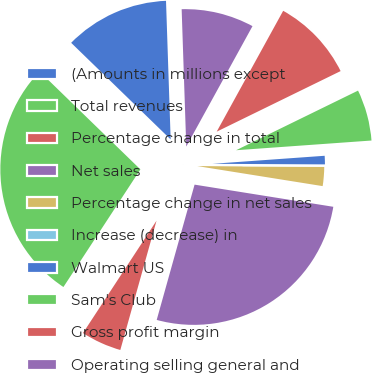<chart> <loc_0><loc_0><loc_500><loc_500><pie_chart><fcel>(Amounts in millions except<fcel>Total revenues<fcel>Percentage change in total<fcel>Net sales<fcel>Percentage change in net sales<fcel>Increase (decrease) in<fcel>Walmart US<fcel>Sam's Club<fcel>Gross profit margin<fcel>Operating selling general and<nl><fcel>12.2%<fcel>28.05%<fcel>4.88%<fcel>26.83%<fcel>2.44%<fcel>0.0%<fcel>1.22%<fcel>6.1%<fcel>9.76%<fcel>8.54%<nl></chart> 